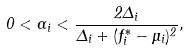Convert formula to latex. <formula><loc_0><loc_0><loc_500><loc_500>0 < \alpha _ { i } < \frac { 2 \Delta _ { i } } { \Delta _ { i } + ( f _ { i } ^ { * } - \mu _ { i } ) ^ { 2 } } ,</formula> 